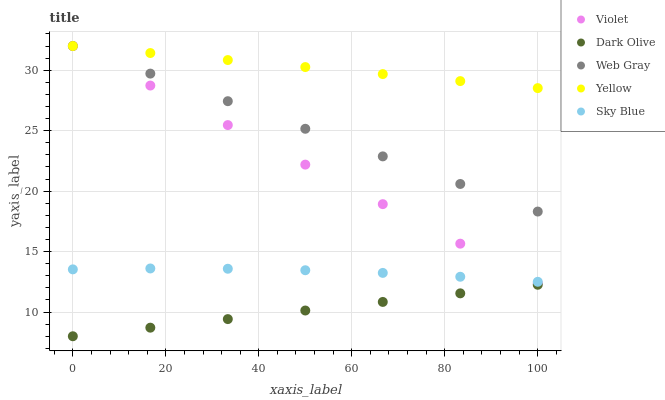Does Dark Olive have the minimum area under the curve?
Answer yes or no. Yes. Does Yellow have the maximum area under the curve?
Answer yes or no. Yes. Does Web Gray have the minimum area under the curve?
Answer yes or no. No. Does Web Gray have the maximum area under the curve?
Answer yes or no. No. Is Dark Olive the smoothest?
Answer yes or no. Yes. Is Sky Blue the roughest?
Answer yes or no. Yes. Is Web Gray the smoothest?
Answer yes or no. No. Is Web Gray the roughest?
Answer yes or no. No. Does Dark Olive have the lowest value?
Answer yes or no. Yes. Does Web Gray have the lowest value?
Answer yes or no. No. Does Violet have the highest value?
Answer yes or no. Yes. Does Dark Olive have the highest value?
Answer yes or no. No. Is Dark Olive less than Web Gray?
Answer yes or no. Yes. Is Yellow greater than Dark Olive?
Answer yes or no. Yes. Does Web Gray intersect Violet?
Answer yes or no. Yes. Is Web Gray less than Violet?
Answer yes or no. No. Is Web Gray greater than Violet?
Answer yes or no. No. Does Dark Olive intersect Web Gray?
Answer yes or no. No. 